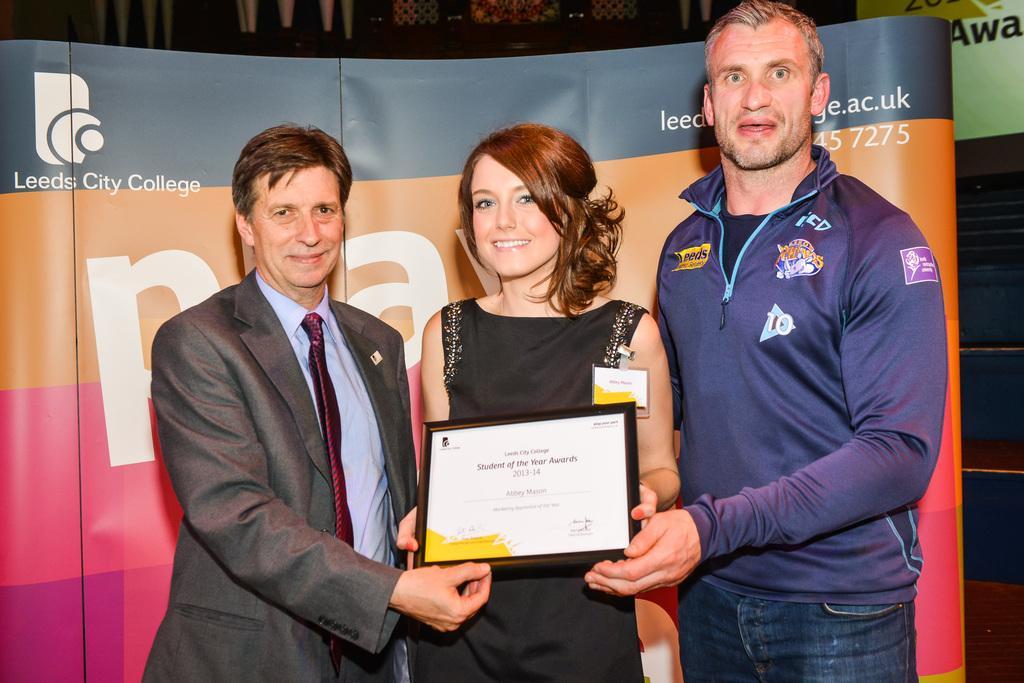In one or two sentences, can you explain what this image depicts? In this picture there are three members standing. Two of them were men and one of them was a woman. She is wearing black color dress and holding a frame in her hands. In the background there is a poster in different colors. 